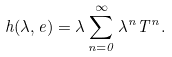<formula> <loc_0><loc_0><loc_500><loc_500>h ( \lambda , e ) = \lambda \sum _ { n = 0 } ^ { \infty } \lambda ^ { n } T ^ { n } .</formula> 